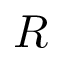Convert formula to latex. <formula><loc_0><loc_0><loc_500><loc_500>R</formula> 